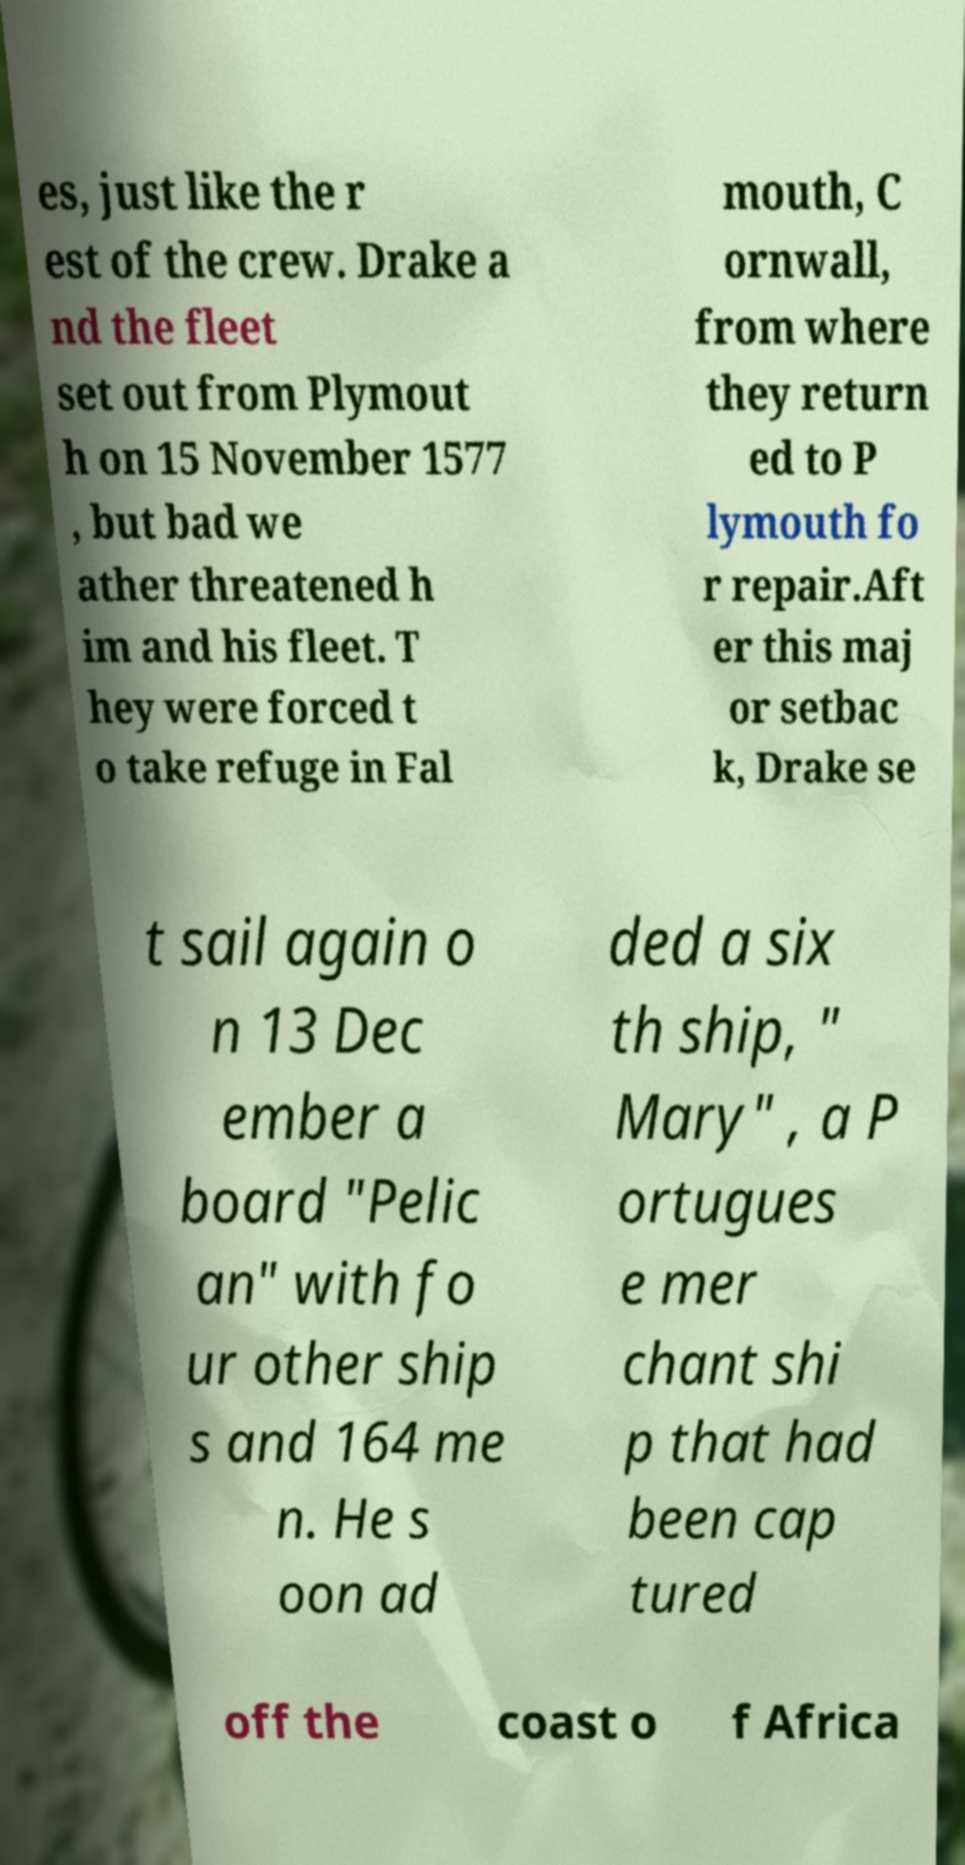Could you assist in decoding the text presented in this image and type it out clearly? es, just like the r est of the crew. Drake a nd the fleet set out from Plymout h on 15 November 1577 , but bad we ather threatened h im and his fleet. T hey were forced t o take refuge in Fal mouth, C ornwall, from where they return ed to P lymouth fo r repair.Aft er this maj or setbac k, Drake se t sail again o n 13 Dec ember a board "Pelic an" with fo ur other ship s and 164 me n. He s oon ad ded a six th ship, " Mary" , a P ortugues e mer chant shi p that had been cap tured off the coast o f Africa 